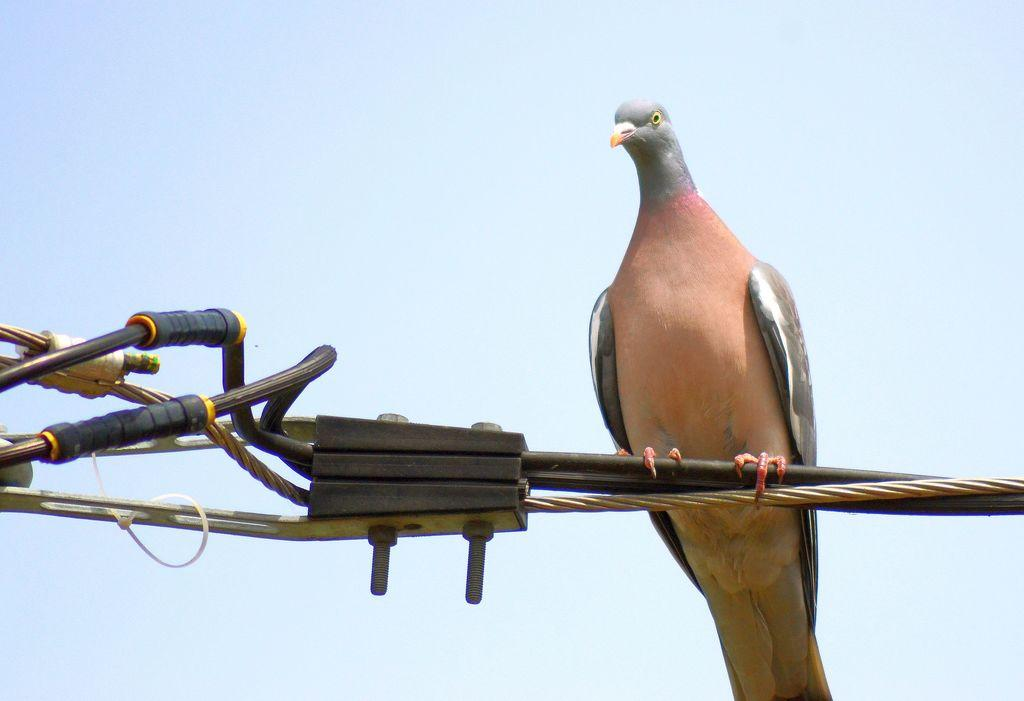What type of bird is in the image? There is a stock dove in the image. Where is the stock dove positioned in the image? The stock dove is on a metal wire. What is the condition of the sky in the image? The sky is cloudy in the image. What type of army equipment can be seen in the image? There is no army equipment present in the image; it features a stock dove on a metal wire with a cloudy sky. What type of shoe is the stock dove wearing in the image? Stock doves do not wear shoes, as they are birds. --- Facts: 1. There is a person holding a camera in the image. 2. The person is standing on a bridge. 3. There is a river visible under the bridge. 4. The sky is visible in the background of the image. Absurd Topics: elephant, piano, ocean Conversation: What is the person in the image holding? The person in the image is holding a camera. Where is the person standing in the image? The person is standing on a bridge. What can be seen under the bridge in the image? There is a river visible under the bridge. What is visible in the background of the image? The sky is visible in the background of the image. Reasoning: Let's think step by step in order to produce the conversation. We start by identifying the main subject in the image, which is the person holding a camera. Then, we describe the specific location of the person, which is on a bridge. Next, we mention the presence of a river under the bridge. Finally, we describe the background of the image, which is the sky. Absurd Question/Answer: Can you tell me how many elephants are swimming in the ocean in the image? There are no elephants or ocean present in the image; it features a person holding a camera on a bridge with a river and sky visible. What type of piano can be seen being played by the person in the image? There is no piano present in the image; the person is holding a camera while standing on a bridge. 